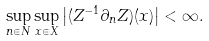Convert formula to latex. <formula><loc_0><loc_0><loc_500><loc_500>\sup _ { n \in N } \sup _ { x \in X } \left | ( Z ^ { - 1 } \partial _ { n } Z ) ( x ) \right | < \infty .</formula> 